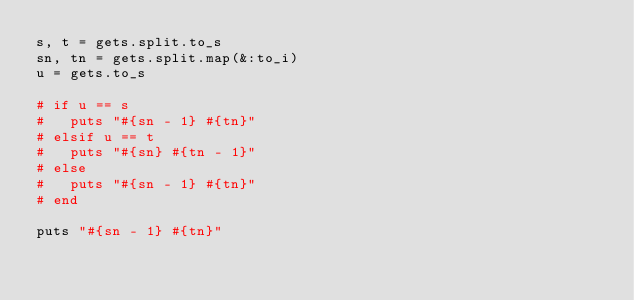Convert code to text. <code><loc_0><loc_0><loc_500><loc_500><_Ruby_>s, t = gets.split.to_s
sn, tn = gets.split.map(&:to_i)
u = gets.to_s

# if u == s
#   puts "#{sn - 1} #{tn}"
# elsif u == t
#   puts "#{sn} #{tn - 1}"
# else
#   puts "#{sn - 1} #{tn}"
# end

puts "#{sn - 1} #{tn}"</code> 